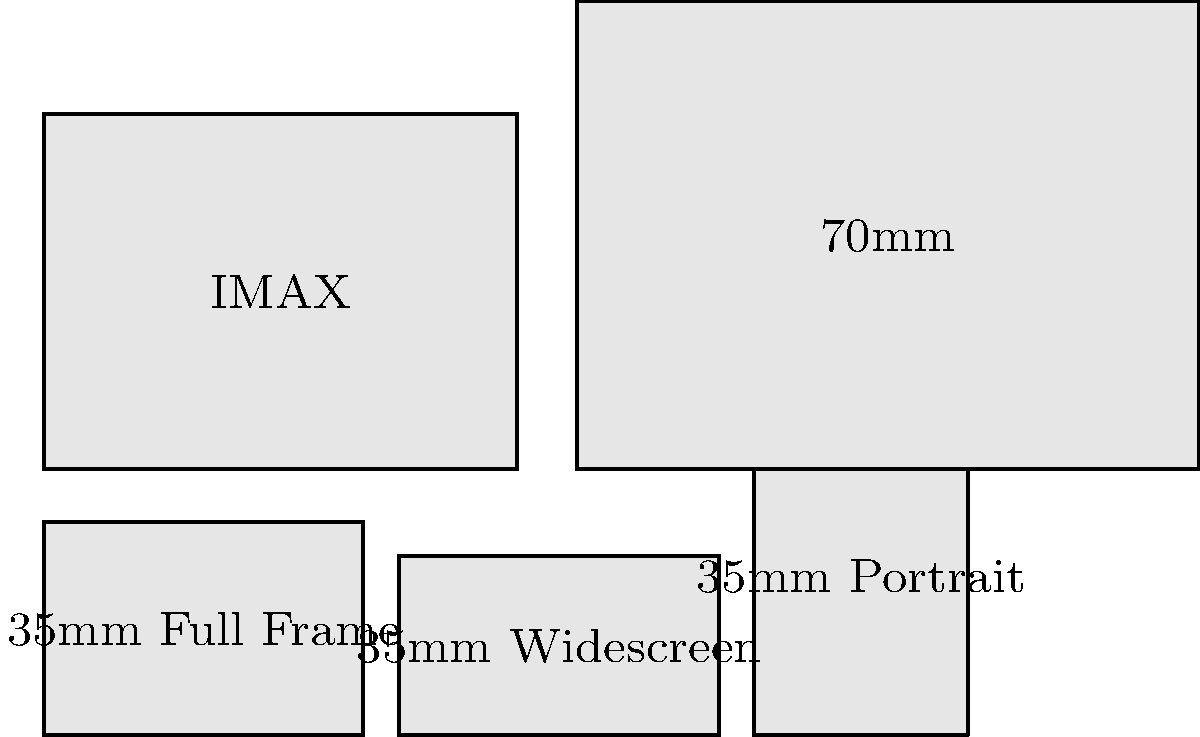As a professional movie reviewer, you're often asked about different film formats. Based on the scaled rectangles shown in the image, which film format has the largest area and how does it compare to the standard 35mm Full Frame format? To determine which film format has the largest area and compare it to the 35mm Full Frame format, let's follow these steps:

1. Calculate the areas of each film format:
   a) 35mm Full Frame: $36 \times 24 = 864 \text{ mm}^2$
   b) 35mm Widescreen: $36 \times 20.25 = 729 \text{ mm}^2$
   c) 35mm Portrait: $24 \times 36 = 864 \text{ mm}^2$
   d) IMAX: $53.34 \times 40.01 = 2134.13 \text{ mm}^2$
   e) 70mm: $70 \times 52.63 = 3684.1 \text{ mm}^2$

2. Identify the largest area:
   The 70mm format has the largest area at $3684.1 \text{ mm}^2$.

3. Compare the 70mm format to the 35mm Full Frame:
   $\frac{3684.1}{864} \approx 4.26$

Therefore, the 70mm format is approximately 4.26 times larger than the standard 35mm Full Frame format.
Answer: 70mm, 4.26 times larger than 35mm Full Frame 